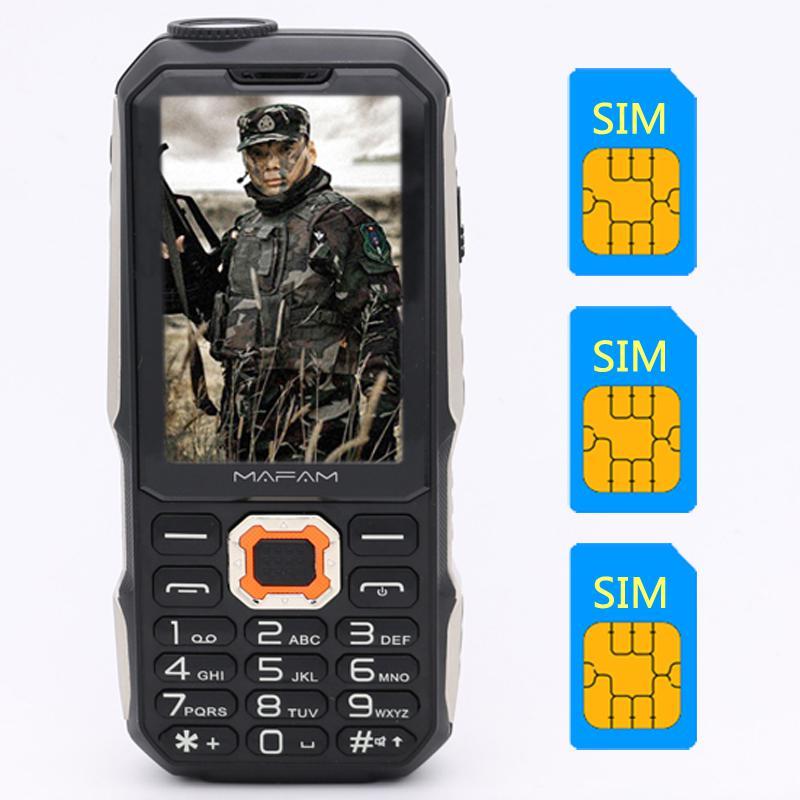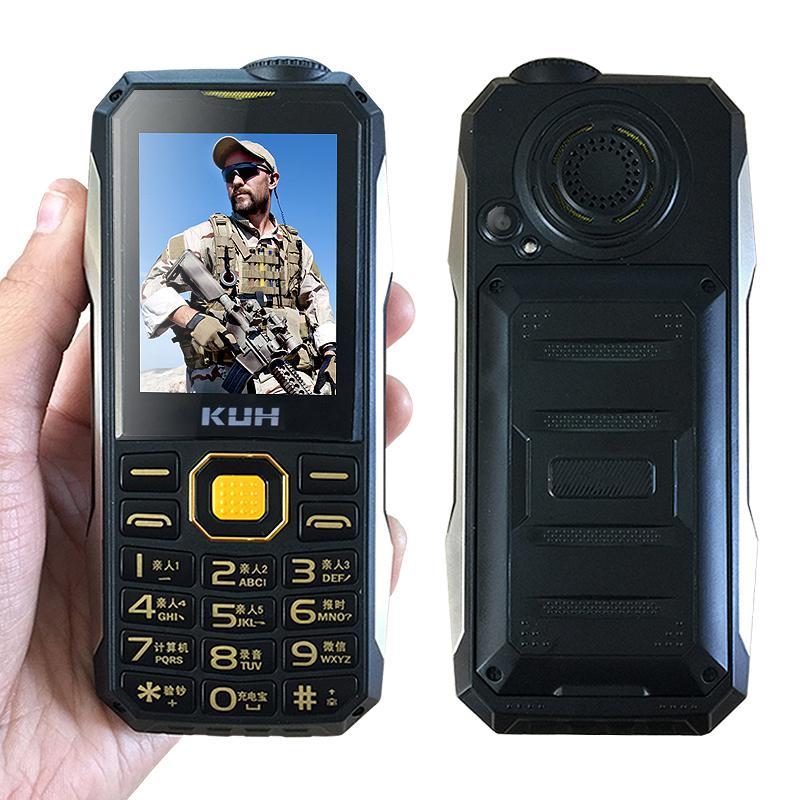The first image is the image on the left, the second image is the image on the right. Examine the images to the left and right. Is the description "One image contains just the front side of a phone and the other image shows both the front and back side of a phone." accurate? Answer yes or no. Yes. The first image is the image on the left, the second image is the image on the right. Analyze the images presented: Is the assertion "There are two phones in one of the images and one phone in the other." valid? Answer yes or no. Yes. 